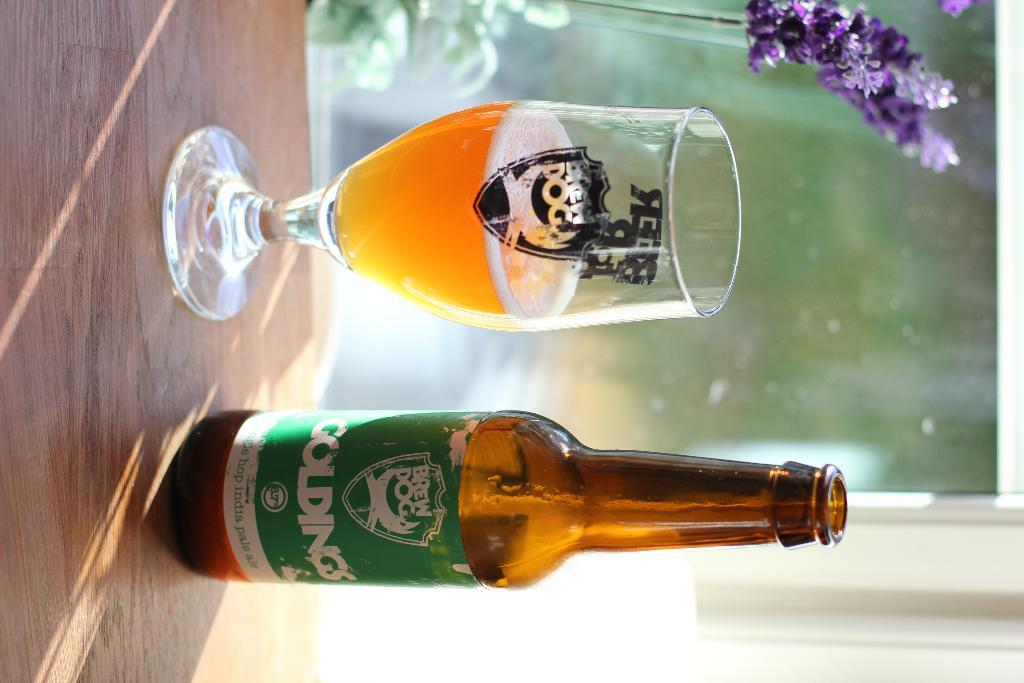<image>
Present a compact description of the photo's key features. a bottle of goldings india pale ale standing next to a glass of it 